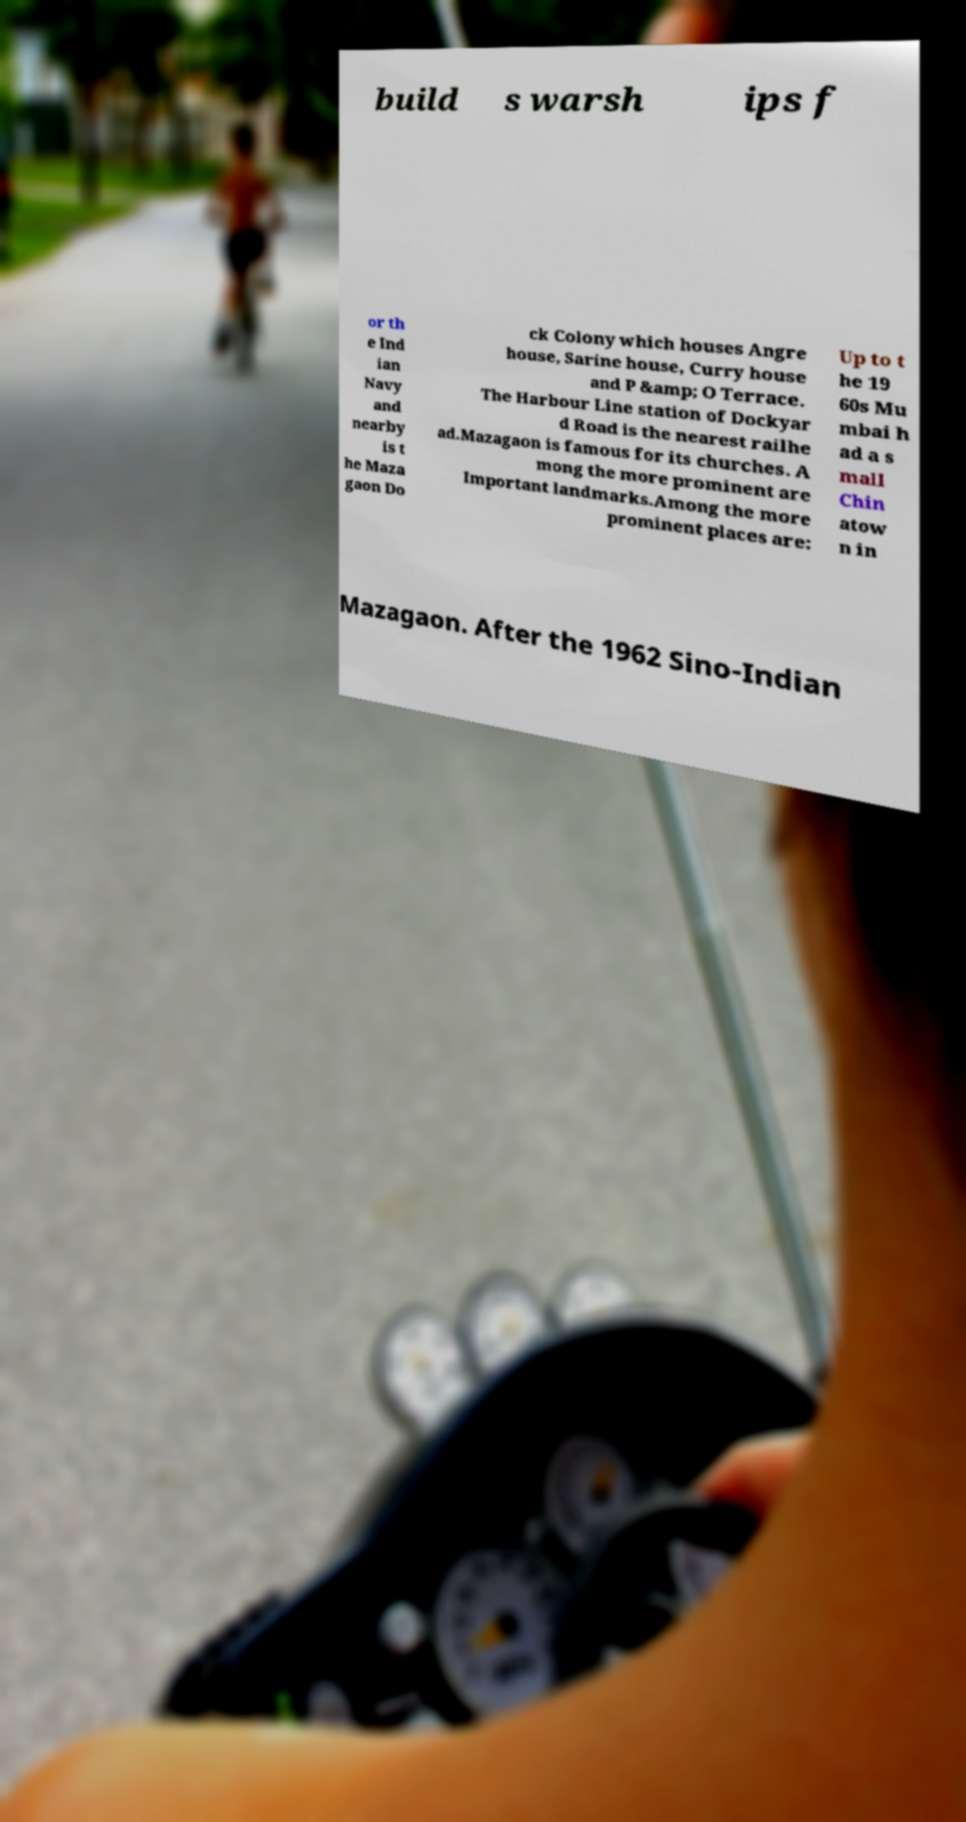Could you extract and type out the text from this image? build s warsh ips f or th e Ind ian Navy and nearby is t he Maza gaon Do ck Colony which houses Angre house, Sarine house, Curry house and P &amp; O Terrace. The Harbour Line station of Dockyar d Road is the nearest railhe ad.Mazagaon is famous for its churches. A mong the more prominent are Important landmarks.Among the more prominent places are: Up to t he 19 60s Mu mbai h ad a s mall Chin atow n in Mazagaon. After the 1962 Sino-Indian 